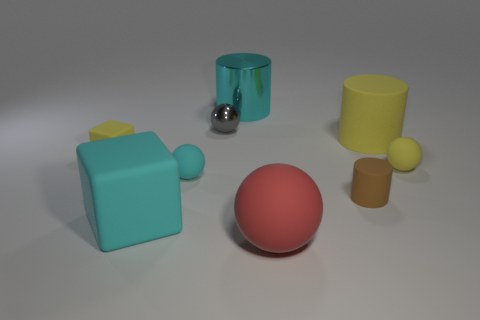Subtract all large cylinders. How many cylinders are left? 1 Subtract 1 balls. How many balls are left? 3 Subtract all yellow spheres. How many spheres are left? 3 Subtract all blue spheres. Subtract all cyan cylinders. How many spheres are left? 4 Add 1 tiny yellow metal cylinders. How many objects exist? 10 Subtract all cubes. How many objects are left? 7 Subtract all large red spheres. Subtract all small metallic things. How many objects are left? 7 Add 7 tiny yellow blocks. How many tiny yellow blocks are left? 8 Add 5 red matte things. How many red matte things exist? 6 Subtract 0 blue cylinders. How many objects are left? 9 